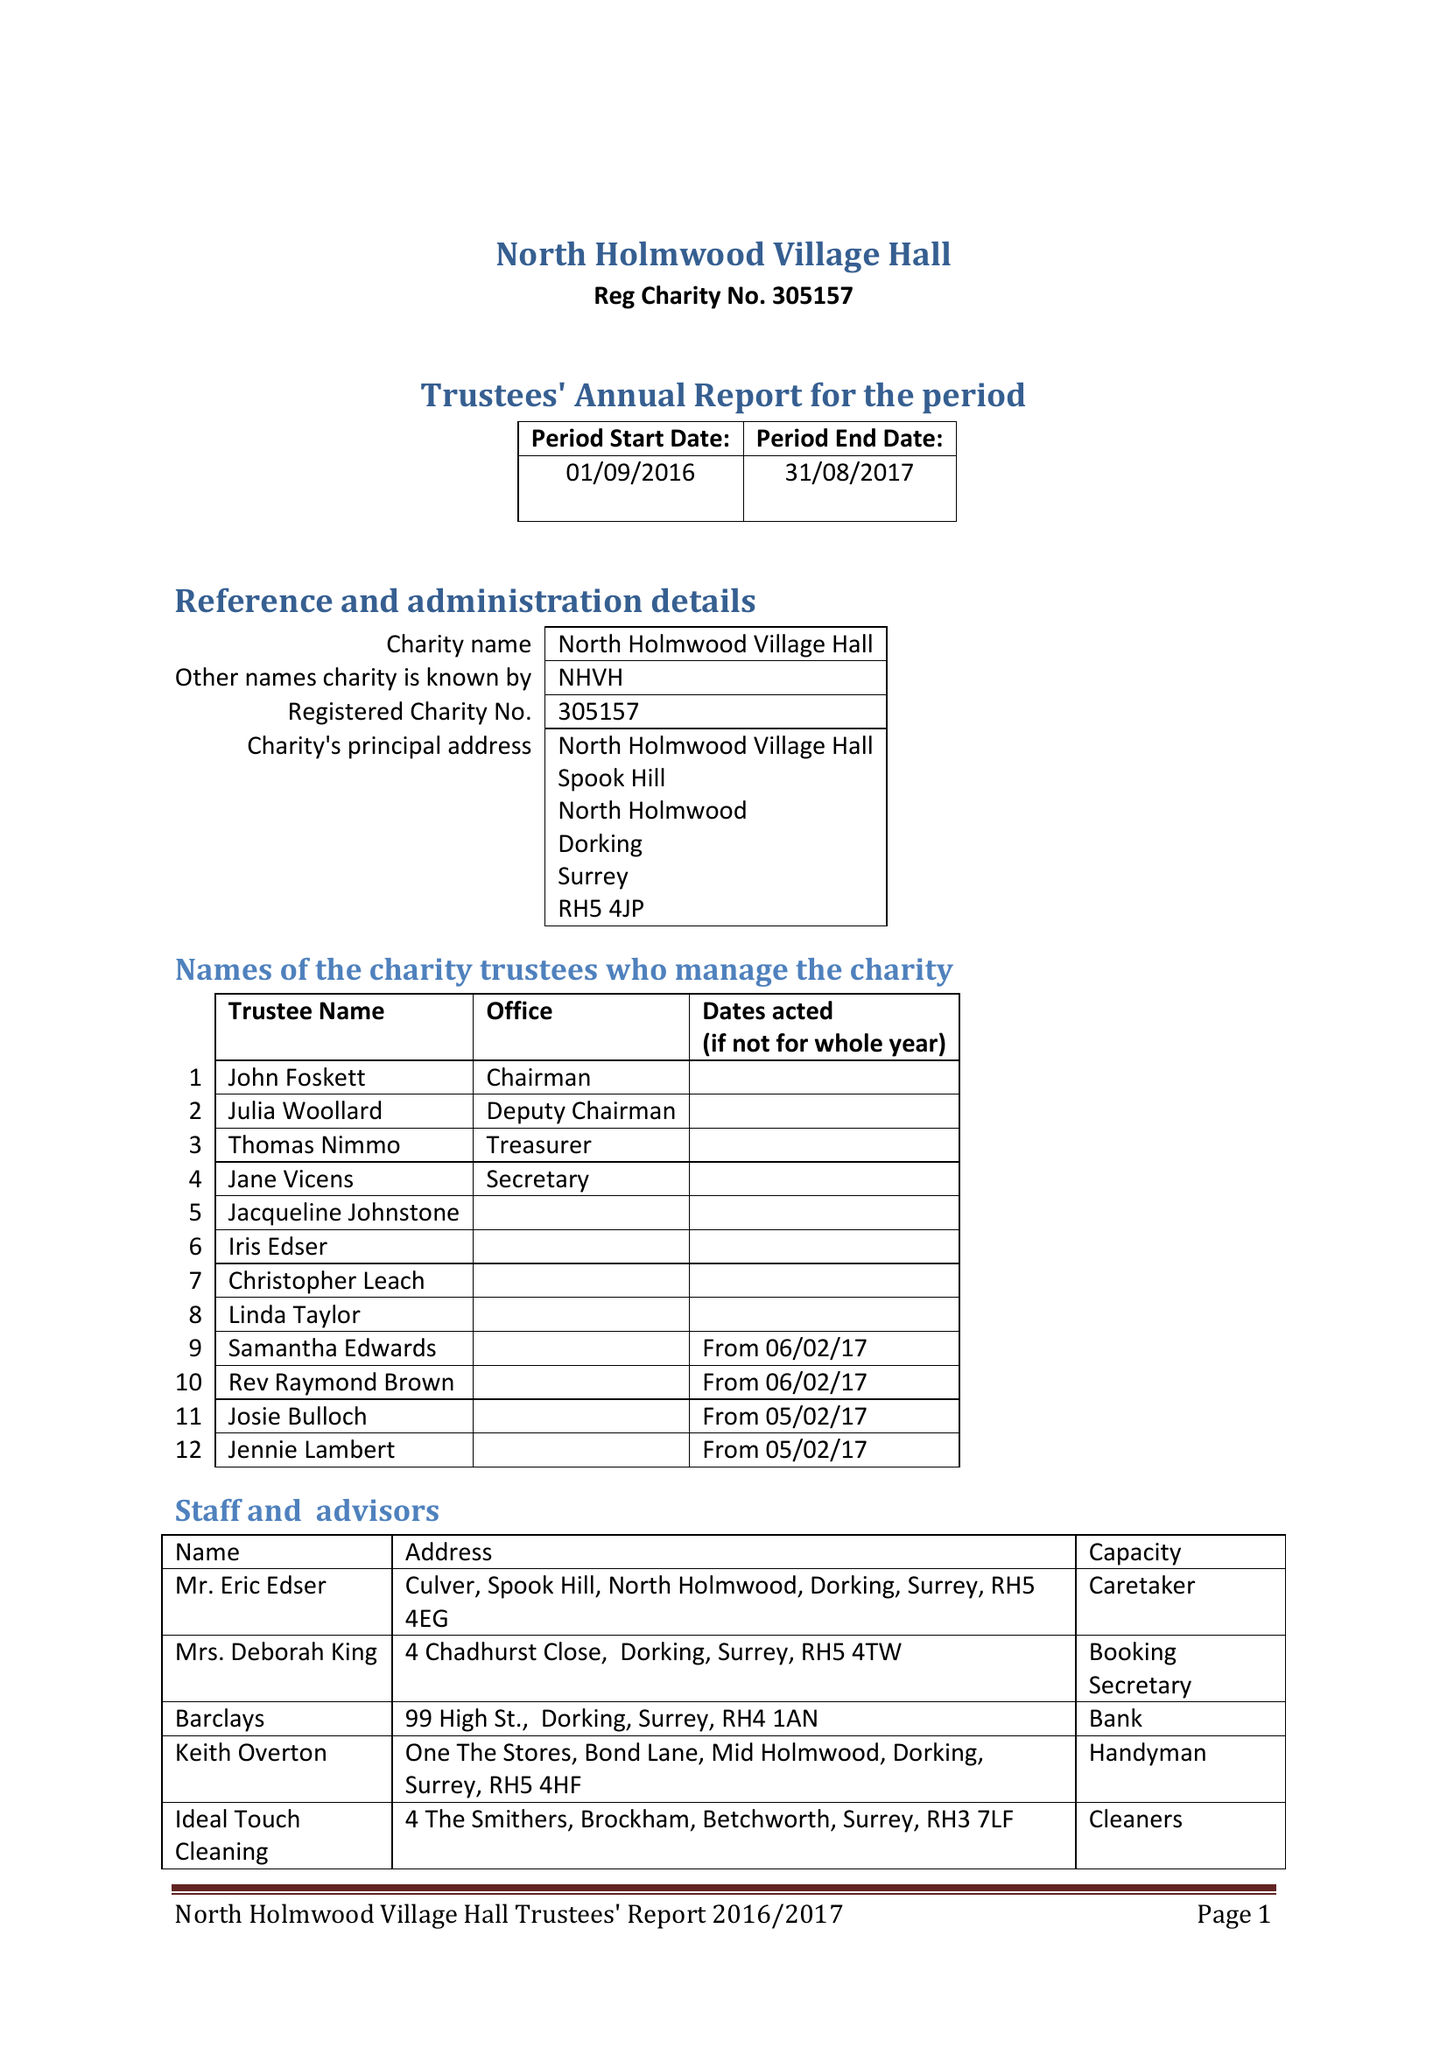What is the value for the address__street_line?
Answer the question using a single word or phrase. SPOOK HILL 